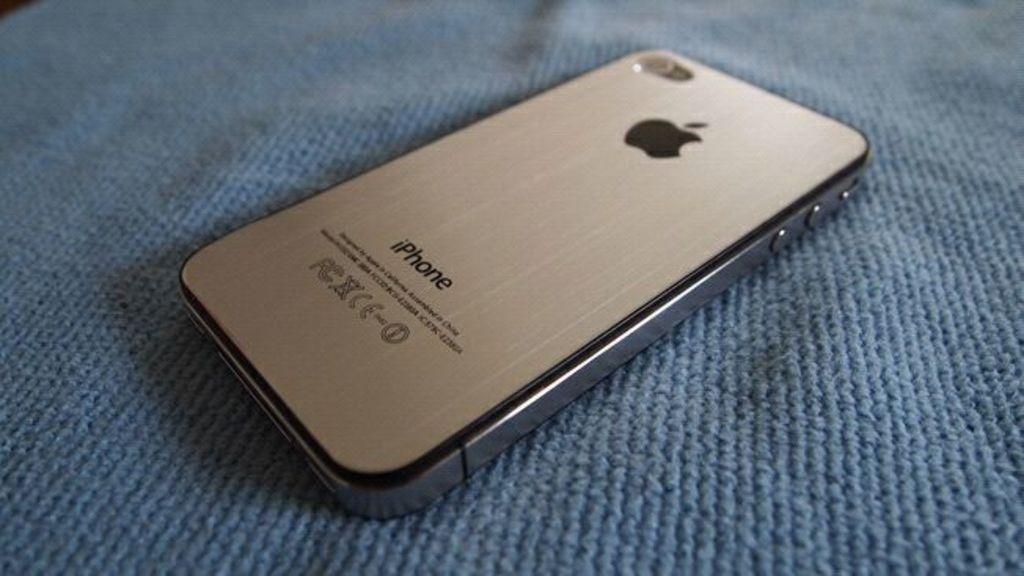What brand of phone is this?
Offer a terse response. Iphone. What is the first letter of the brand of the phone?
Provide a succinct answer. I. 